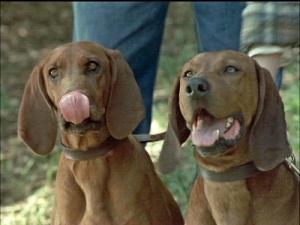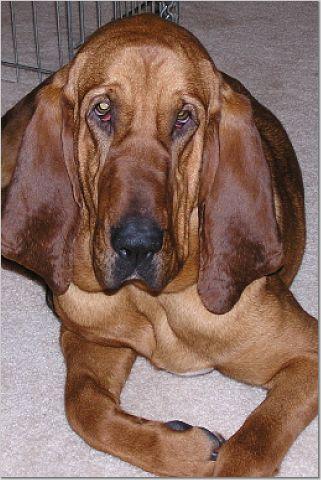The first image is the image on the left, the second image is the image on the right. Examine the images to the left and right. Is the description "At least two dogs with upright heads and shoulders are near a pair of legs in blue jeans." accurate? Answer yes or no. Yes. The first image is the image on the left, the second image is the image on the right. Analyze the images presented: Is the assertion "At least three dogs are visible." valid? Answer yes or no. Yes. 